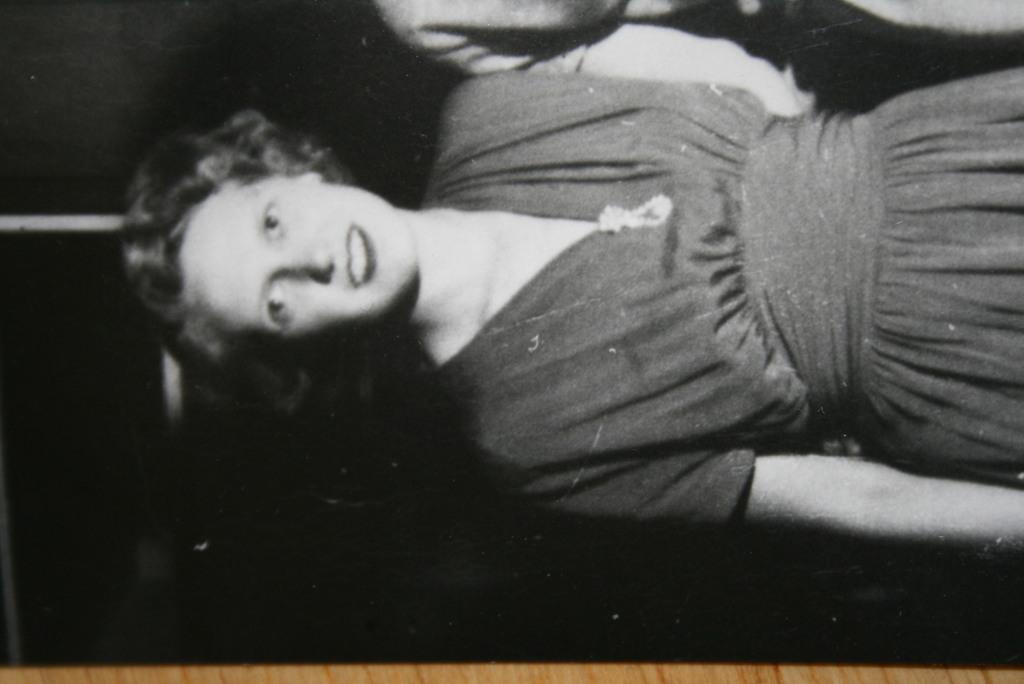Describe this image in one or two sentences. In black and white image, we can see a person wearing clothes. There is an another person hand at the top of the image. 